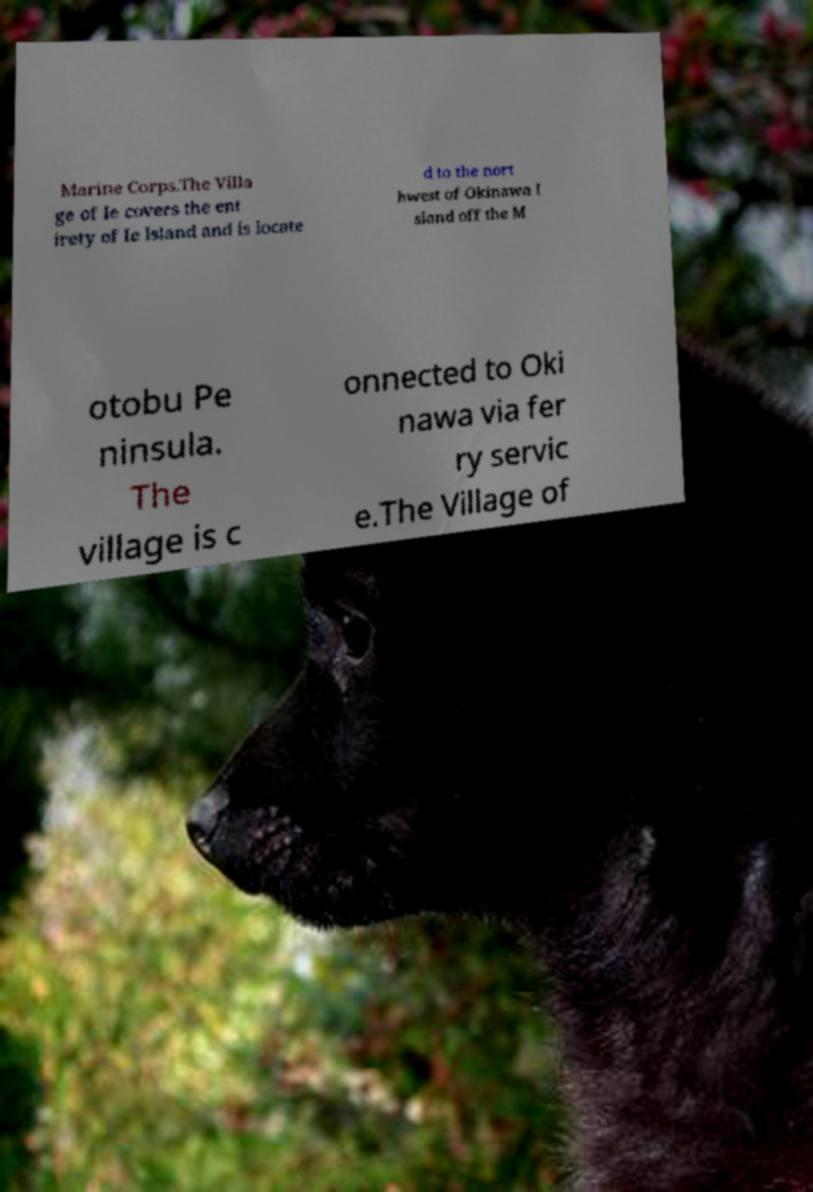Can you accurately transcribe the text from the provided image for me? Marine Corps.The Villa ge of Ie covers the ent irety of Ie Island and is locate d to the nort hwest of Okinawa I sland off the M otobu Pe ninsula. The village is c onnected to Oki nawa via fer ry servic e.The Village of 